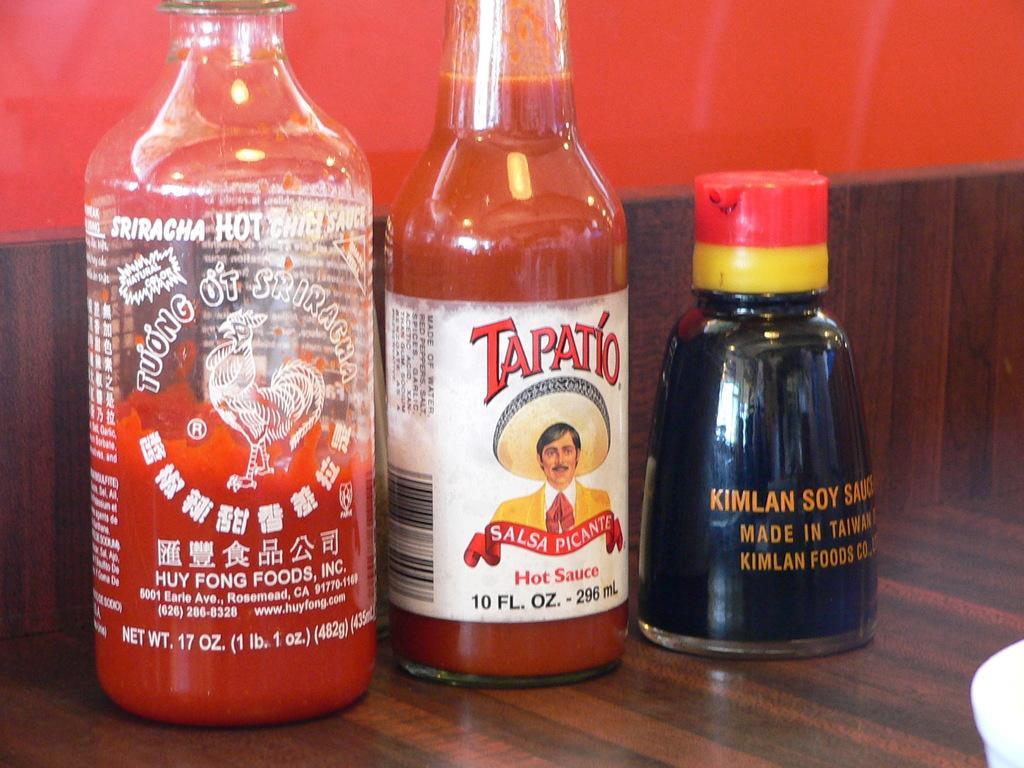How would you summarize this image in a sentence or two? In this picture we can see three bottles some drink in it and on bottle we can see stickers and this are placed on a wooden floor. 